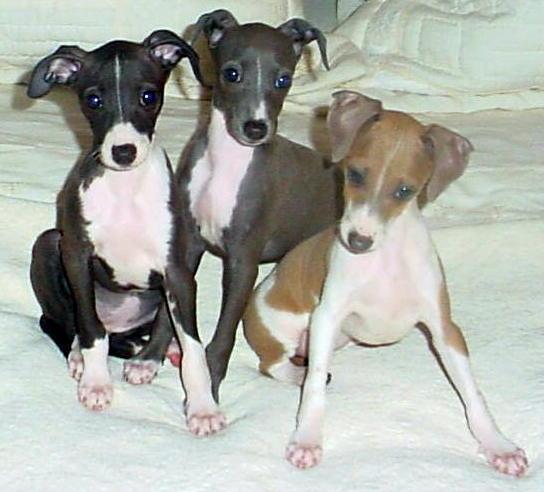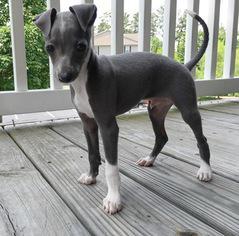The first image is the image on the left, the second image is the image on the right. Considering the images on both sides, is "Each image contains a single dog, and all dogs are charcoal gray with white markings." valid? Answer yes or no. No. 